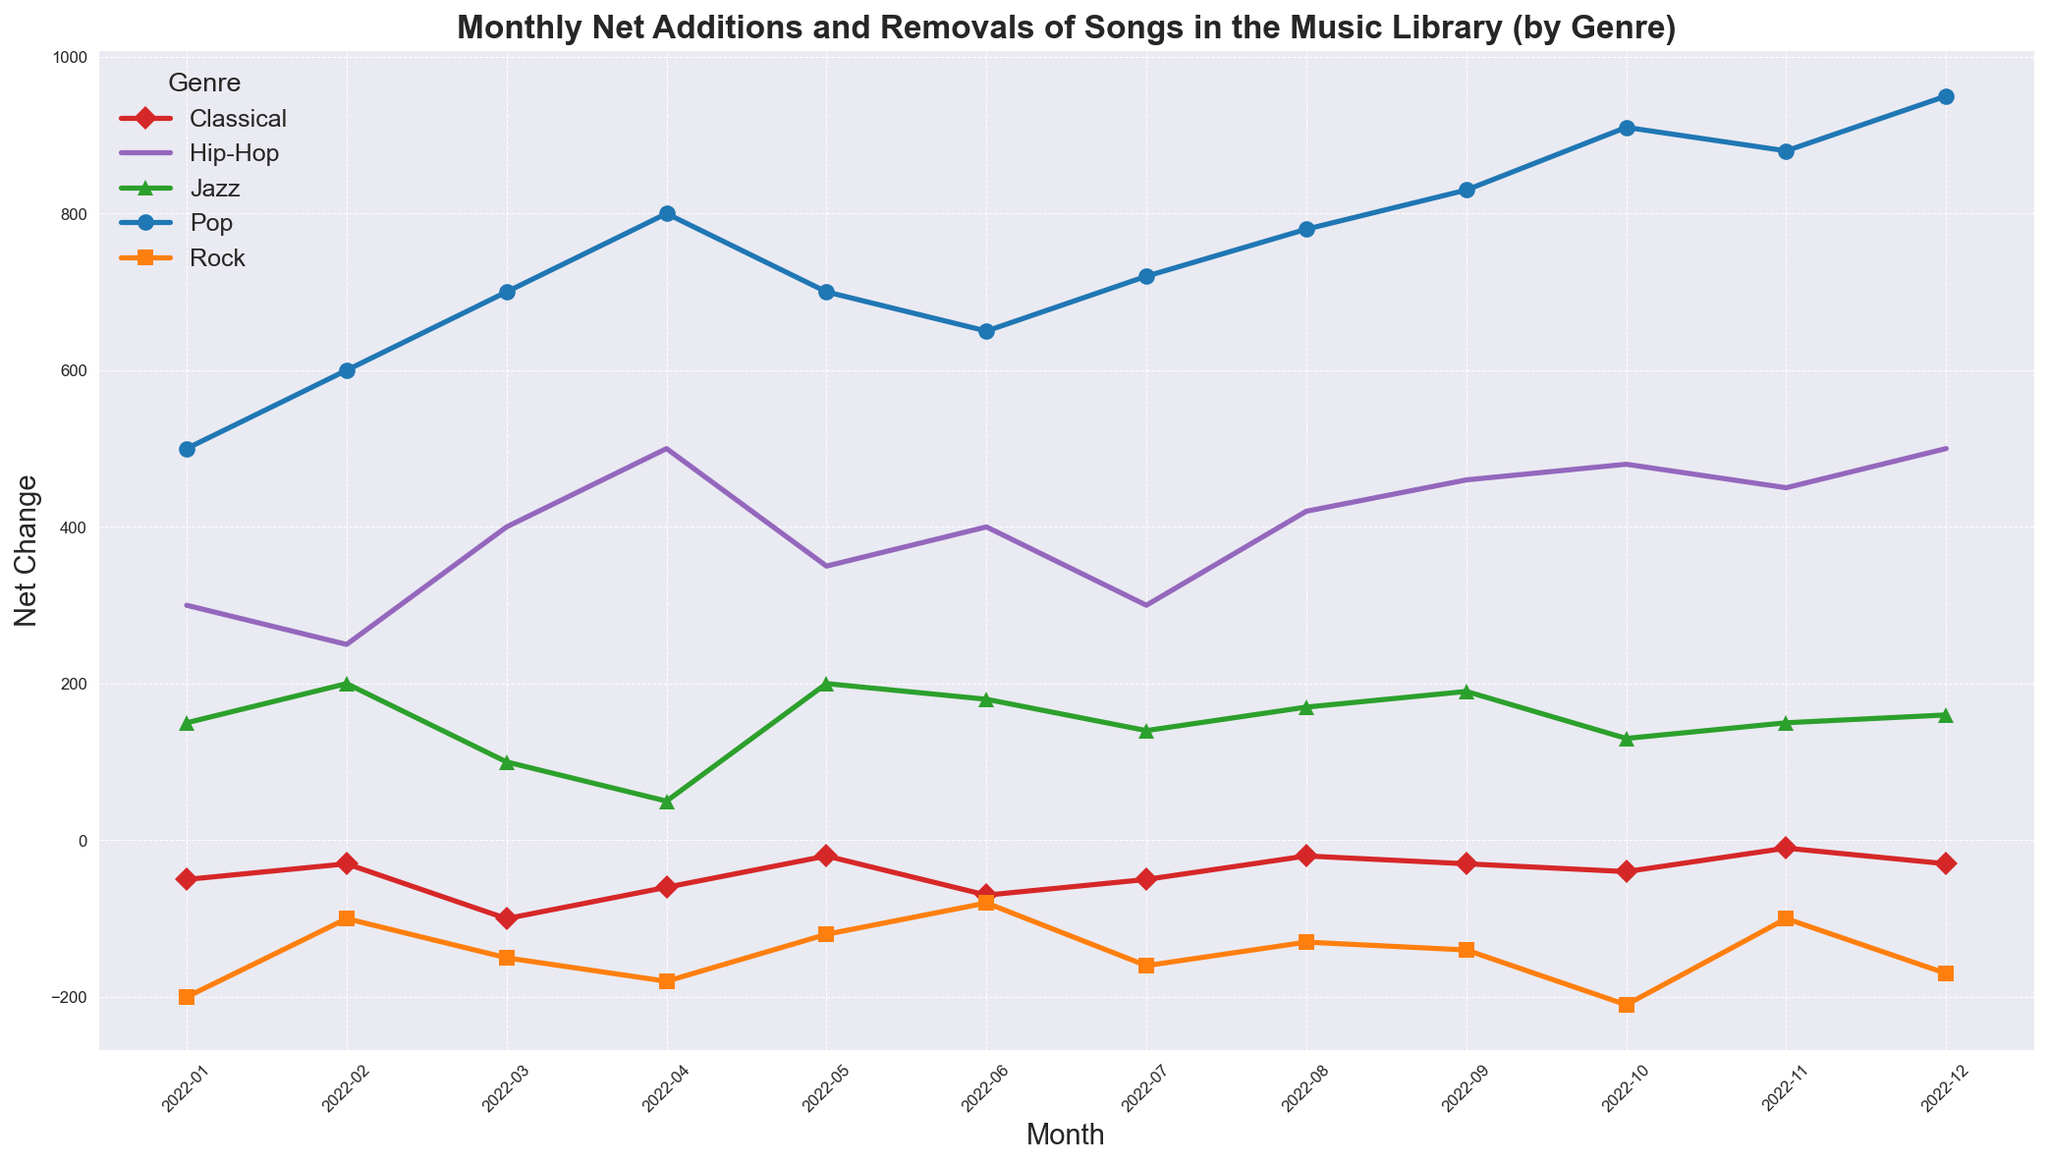what genre showed the largest net increase in songs in the last month? Look at the net changes for each genre in December 2022 and identify the highest positive value. Pop had a net addition of 950 songs, higher than the other genres.
Answer: Pop which genre had the most frequent net removals throughout the year? Check the monthly net changes for each genre over the year and count the number of months with negative values. Rock often had negative monthly changes.
Answer: Rock did any genre consistently show net increases across all months? Check the net changes for each genre in all months, ensuring all values are positive for any genre. Pop and Hip-Hop consistently showed positive net changes.
Answer: Pop and Hip-Hop for which month did Jazz show its highest net addition? Look at the net changes for Jazz across all months and identify the highest positive value. The highest was in May 2022, with 200.
Answer: May 2022 what is the difference between the highest and lowest net changes for Classical music in the year? Identify the highest (which is -10 in November 2022) and lowest (which is -100 in March 2022) values for Classical, and calculate the difference. The difference is 90.
Answer: 90 which month experienced the most net additions in the music library across all genres combined? Sum the net changes for all genres in each month and identify the month with the highest sum. December 2022 had the highest cumulative addition.
Answer: December 2022 how did Hip-Hop’s net additions compare between the beginning and end of the year? Look at the net changes for Hip-Hop in January 2022 (300) and December 2022 (500), and compare these values. The net addition in December 2022 was 200 more than in January 2022.
Answer: 200 more what was the average monthly net change for Rock throughout the year? Sum the net changes for Rock in all months and divide by the number of months (12). The sum is -1740, so the average is -1740/12 = -145.
Answer: -145 which genre reported the highest net decrease in any single month? Identify the lowest (most negative) monthly net change across all genres. Rock had a net decrease of -210 in October 2022.
Answer: Rock 